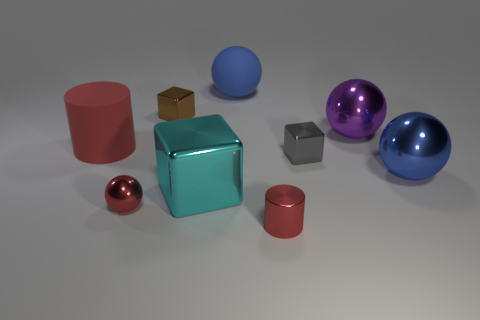There is a cyan object that is made of the same material as the small ball; what is its shape?
Your answer should be compact. Cube. Is the gray metal block the same size as the blue metallic sphere?
Keep it short and to the point. No. There is a blue sphere in front of the red cylinder to the left of the large blue rubber thing; how big is it?
Your response must be concise. Large. What is the shape of the large object that is the same color as the small cylinder?
Offer a terse response. Cylinder. What number of spheres are red shiny things or big objects?
Give a very brief answer. 4. There is a blue metallic ball; is its size the same as the purple thing in front of the large rubber sphere?
Offer a terse response. Yes. Are there more small gray objects that are in front of the red metallic ball than large red rubber objects?
Offer a very short reply. No. The gray block that is the same material as the big cyan object is what size?
Offer a very short reply. Small. Are there any big metal spheres that have the same color as the tiny cylinder?
Make the answer very short. No. How many things are either big purple objects or tiny blocks in front of the large purple metallic thing?
Give a very brief answer. 2. 